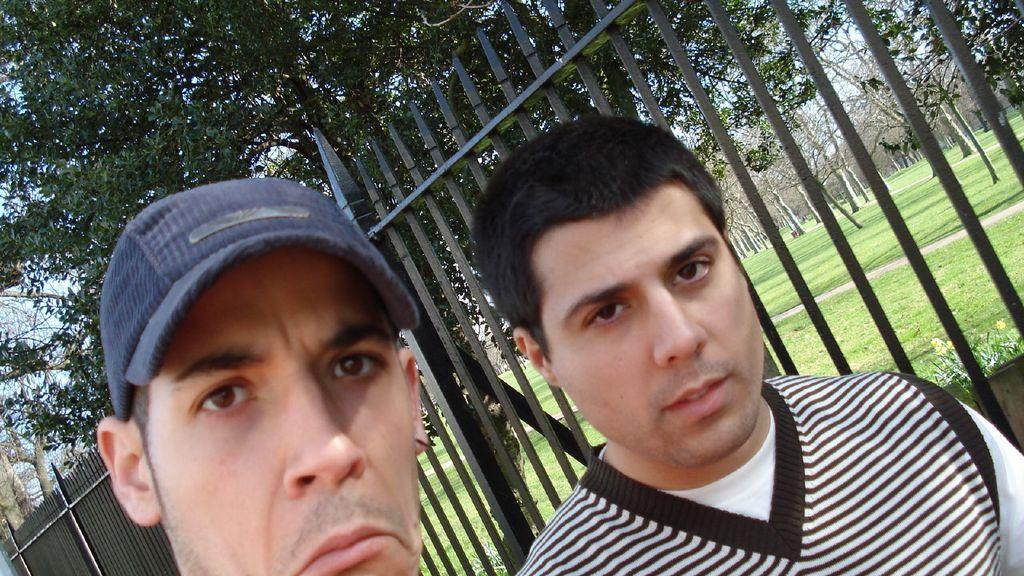Can you describe this image briefly? In this image we can see men, iron grills, trees, ground and sky. 